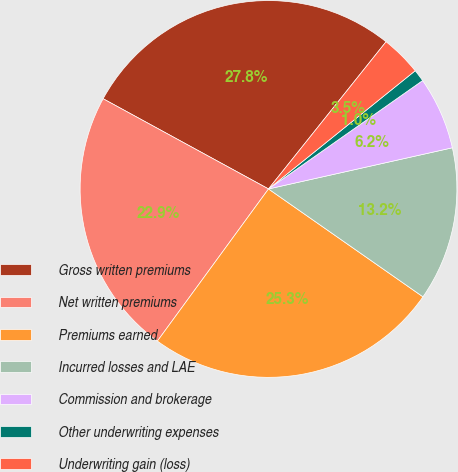Convert chart to OTSL. <chart><loc_0><loc_0><loc_500><loc_500><pie_chart><fcel>Gross written premiums<fcel>Net written premiums<fcel>Premiums earned<fcel>Incurred losses and LAE<fcel>Commission and brokerage<fcel>Other underwriting expenses<fcel>Underwriting gain (loss)<nl><fcel>27.78%<fcel>22.91%<fcel>25.34%<fcel>13.21%<fcel>6.25%<fcel>1.04%<fcel>3.48%<nl></chart> 